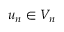Convert formula to latex. <formula><loc_0><loc_0><loc_500><loc_500>u _ { n } \in V _ { n }</formula> 